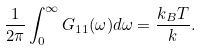<formula> <loc_0><loc_0><loc_500><loc_500>\frac { 1 } { 2 \pi } \int ^ { \infty } _ { 0 } G _ { 1 1 } ( \omega ) d \omega = \frac { k _ { B } T } { k } .</formula> 